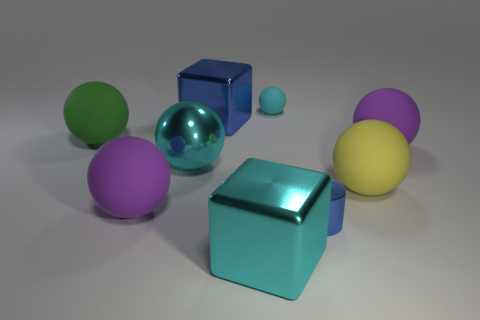Is there anything else that has the same shape as the small blue shiny thing?
Give a very brief answer. No. How many other things are there of the same color as the large metal sphere?
Your answer should be compact. 2. Do the metal thing on the right side of the big cyan block and the purple matte thing that is in front of the yellow ball have the same size?
Your answer should be very brief. No. Are the big blue cube and the purple thing that is to the right of the big metal sphere made of the same material?
Your response must be concise. No. Is the number of large yellow balls that are in front of the cyan shiny cube greater than the number of small blue metallic cylinders that are on the right side of the yellow thing?
Your answer should be very brief. No. What color is the large shiny thing that is in front of the large purple rubber sphere that is left of the large cyan sphere?
Make the answer very short. Cyan. What number of balls are cyan matte things or tiny shiny objects?
Offer a terse response. 1. How many spheres are both behind the large blue shiny object and in front of the big blue cube?
Your answer should be very brief. 0. There is a large thing in front of the small blue shiny object; what is its color?
Provide a short and direct response. Cyan. There is a green object that is the same material as the small cyan thing; what size is it?
Keep it short and to the point. Large. 